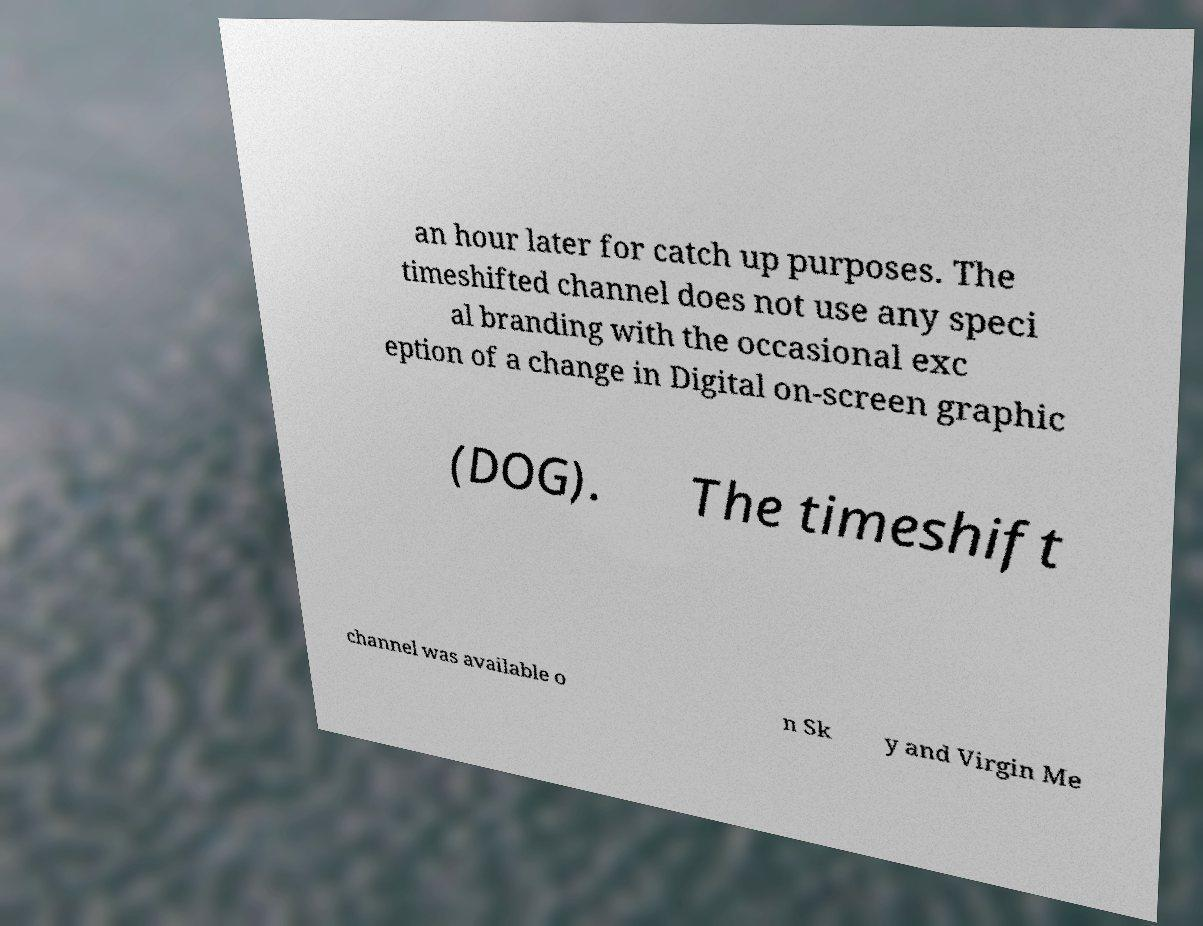What messages or text are displayed in this image? I need them in a readable, typed format. an hour later for catch up purposes. The timeshifted channel does not use any speci al branding with the occasional exc eption of a change in Digital on-screen graphic (DOG). The timeshift channel was available o n Sk y and Virgin Me 